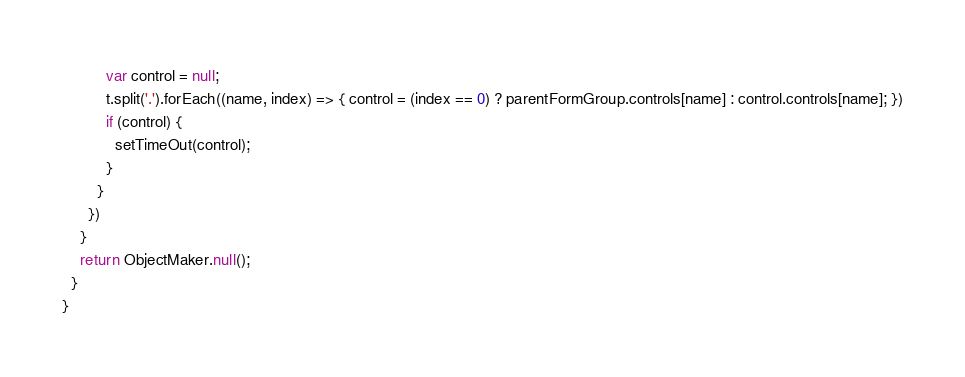Convert code to text. <code><loc_0><loc_0><loc_500><loc_500><_TypeScript_>          var control = null;
          t.split('.').forEach((name, index) => { control = (index == 0) ? parentFormGroup.controls[name] : control.controls[name]; })
          if (control) {
            setTimeOut(control);
          }
        }
      })
    }
    return ObjectMaker.null();
  }
}
</code> 